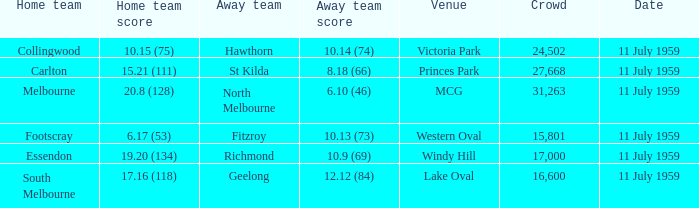What is the home team's score when richmond is away? 19.20 (134). 